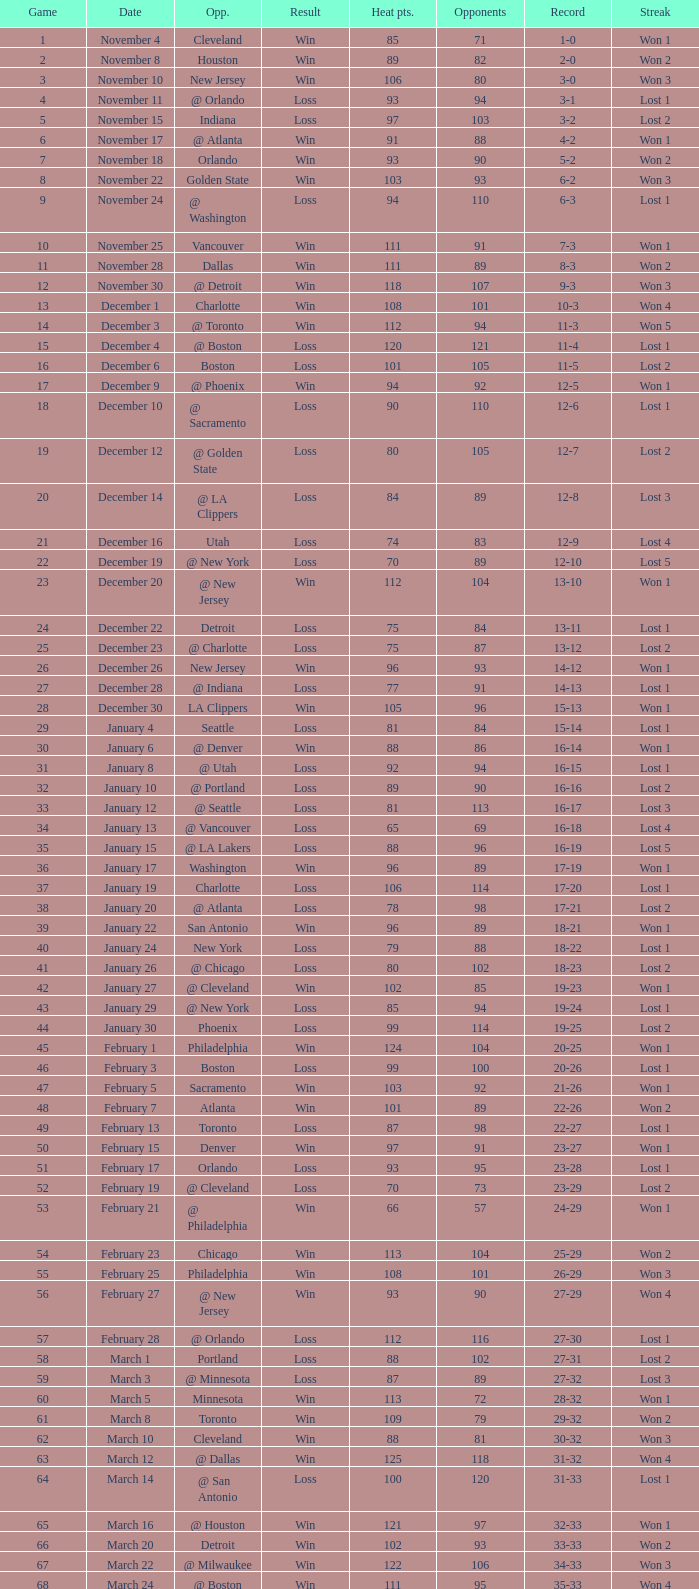Could you parse the entire table? {'header': ['Game', 'Date', 'Opp.', 'Result', 'Heat pts.', 'Opponents', 'Record', 'Streak'], 'rows': [['1', 'November 4', 'Cleveland', 'Win', '85', '71', '1-0', 'Won 1'], ['2', 'November 8', 'Houston', 'Win', '89', '82', '2-0', 'Won 2'], ['3', 'November 10', 'New Jersey', 'Win', '106', '80', '3-0', 'Won 3'], ['4', 'November 11', '@ Orlando', 'Loss', '93', '94', '3-1', 'Lost 1'], ['5', 'November 15', 'Indiana', 'Loss', '97', '103', '3-2', 'Lost 2'], ['6', 'November 17', '@ Atlanta', 'Win', '91', '88', '4-2', 'Won 1'], ['7', 'November 18', 'Orlando', 'Win', '93', '90', '5-2', 'Won 2'], ['8', 'November 22', 'Golden State', 'Win', '103', '93', '6-2', 'Won 3'], ['9', 'November 24', '@ Washington', 'Loss', '94', '110', '6-3', 'Lost 1'], ['10', 'November 25', 'Vancouver', 'Win', '111', '91', '7-3', 'Won 1'], ['11', 'November 28', 'Dallas', 'Win', '111', '89', '8-3', 'Won 2'], ['12', 'November 30', '@ Detroit', 'Win', '118', '107', '9-3', 'Won 3'], ['13', 'December 1', 'Charlotte', 'Win', '108', '101', '10-3', 'Won 4'], ['14', 'December 3', '@ Toronto', 'Win', '112', '94', '11-3', 'Won 5'], ['15', 'December 4', '@ Boston', 'Loss', '120', '121', '11-4', 'Lost 1'], ['16', 'December 6', 'Boston', 'Loss', '101', '105', '11-5', 'Lost 2'], ['17', 'December 9', '@ Phoenix', 'Win', '94', '92', '12-5', 'Won 1'], ['18', 'December 10', '@ Sacramento', 'Loss', '90', '110', '12-6', 'Lost 1'], ['19', 'December 12', '@ Golden State', 'Loss', '80', '105', '12-7', 'Lost 2'], ['20', 'December 14', '@ LA Clippers', 'Loss', '84', '89', '12-8', 'Lost 3'], ['21', 'December 16', 'Utah', 'Loss', '74', '83', '12-9', 'Lost 4'], ['22', 'December 19', '@ New York', 'Loss', '70', '89', '12-10', 'Lost 5'], ['23', 'December 20', '@ New Jersey', 'Win', '112', '104', '13-10', 'Won 1'], ['24', 'December 22', 'Detroit', 'Loss', '75', '84', '13-11', 'Lost 1'], ['25', 'December 23', '@ Charlotte', 'Loss', '75', '87', '13-12', 'Lost 2'], ['26', 'December 26', 'New Jersey', 'Win', '96', '93', '14-12', 'Won 1'], ['27', 'December 28', '@ Indiana', 'Loss', '77', '91', '14-13', 'Lost 1'], ['28', 'December 30', 'LA Clippers', 'Win', '105', '96', '15-13', 'Won 1'], ['29', 'January 4', 'Seattle', 'Loss', '81', '84', '15-14', 'Lost 1'], ['30', 'January 6', '@ Denver', 'Win', '88', '86', '16-14', 'Won 1'], ['31', 'January 8', '@ Utah', 'Loss', '92', '94', '16-15', 'Lost 1'], ['32', 'January 10', '@ Portland', 'Loss', '89', '90', '16-16', 'Lost 2'], ['33', 'January 12', '@ Seattle', 'Loss', '81', '113', '16-17', 'Lost 3'], ['34', 'January 13', '@ Vancouver', 'Loss', '65', '69', '16-18', 'Lost 4'], ['35', 'January 15', '@ LA Lakers', 'Loss', '88', '96', '16-19', 'Lost 5'], ['36', 'January 17', 'Washington', 'Win', '96', '89', '17-19', 'Won 1'], ['37', 'January 19', 'Charlotte', 'Loss', '106', '114', '17-20', 'Lost 1'], ['38', 'January 20', '@ Atlanta', 'Loss', '78', '98', '17-21', 'Lost 2'], ['39', 'January 22', 'San Antonio', 'Win', '96', '89', '18-21', 'Won 1'], ['40', 'January 24', 'New York', 'Loss', '79', '88', '18-22', 'Lost 1'], ['41', 'January 26', '@ Chicago', 'Loss', '80', '102', '18-23', 'Lost 2'], ['42', 'January 27', '@ Cleveland', 'Win', '102', '85', '19-23', 'Won 1'], ['43', 'January 29', '@ New York', 'Loss', '85', '94', '19-24', 'Lost 1'], ['44', 'January 30', 'Phoenix', 'Loss', '99', '114', '19-25', 'Lost 2'], ['45', 'February 1', 'Philadelphia', 'Win', '124', '104', '20-25', 'Won 1'], ['46', 'February 3', 'Boston', 'Loss', '99', '100', '20-26', 'Lost 1'], ['47', 'February 5', 'Sacramento', 'Win', '103', '92', '21-26', 'Won 1'], ['48', 'February 7', 'Atlanta', 'Win', '101', '89', '22-26', 'Won 2'], ['49', 'February 13', 'Toronto', 'Loss', '87', '98', '22-27', 'Lost 1'], ['50', 'February 15', 'Denver', 'Win', '97', '91', '23-27', 'Won 1'], ['51', 'February 17', 'Orlando', 'Loss', '93', '95', '23-28', 'Lost 1'], ['52', 'February 19', '@ Cleveland', 'Loss', '70', '73', '23-29', 'Lost 2'], ['53', 'February 21', '@ Philadelphia', 'Win', '66', '57', '24-29', 'Won 1'], ['54', 'February 23', 'Chicago', 'Win', '113', '104', '25-29', 'Won 2'], ['55', 'February 25', 'Philadelphia', 'Win', '108', '101', '26-29', 'Won 3'], ['56', 'February 27', '@ New Jersey', 'Win', '93', '90', '27-29', 'Won 4'], ['57', 'February 28', '@ Orlando', 'Loss', '112', '116', '27-30', 'Lost 1'], ['58', 'March 1', 'Portland', 'Loss', '88', '102', '27-31', 'Lost 2'], ['59', 'March 3', '@ Minnesota', 'Loss', '87', '89', '27-32', 'Lost 3'], ['60', 'March 5', 'Minnesota', 'Win', '113', '72', '28-32', 'Won 1'], ['61', 'March 8', 'Toronto', 'Win', '109', '79', '29-32', 'Won 2'], ['62', 'March 10', 'Cleveland', 'Win', '88', '81', '30-32', 'Won 3'], ['63', 'March 12', '@ Dallas', 'Win', '125', '118', '31-32', 'Won 4'], ['64', 'March 14', '@ San Antonio', 'Loss', '100', '120', '31-33', 'Lost 1'], ['65', 'March 16', '@ Houston', 'Win', '121', '97', '32-33', 'Won 1'], ['66', 'March 20', 'Detroit', 'Win', '102', '93', '33-33', 'Won 2'], ['67', 'March 22', '@ Milwaukee', 'Win', '122', '106', '34-33', 'Won 3'], ['68', 'March 24', '@ Boston', 'Win', '111', '95', '35-33', 'Won 4'], ['69', 'March 27', 'LA Lakers', 'Loss', '95', '106', '35-34', 'Lost 1'], ['70', 'March 29', 'Washington', 'Win', '112', '93', '36-34', 'Won 1'], ['71', 'March 30', '@ Detroit', 'Win', '95', '85', '37-34', 'Won 2'], ['72', 'April 2', 'Chicago', 'Loss', '92', '110', '37-35', 'Lost 1'], ['73', 'April 4', '@ Chicago', 'Loss', '92', '100', '37-36', 'Lost 2'], ['74', 'April 6', '@ Indiana', 'Loss', '95', '99', '37-37', 'Lost 3'], ['75', 'April 8', '@ Washington', 'Loss', '99', '111', '37-38', 'Lost 4'], ['76', 'April 10', '@ Charlotte', 'Win', '116', '95', '38-38', 'Won 1'], ['77', 'April 11', 'Milwaukee', 'Win', '115', '105', '39-38', 'Won 2'], ['78', 'April 13', 'New York', 'Win', '103', '95', '40-38', 'Won 3'], ['79', 'April 15', 'New Jersey', 'Win', '110', '90', '41-38', 'Won 4'], ['80', 'April 17', '@ Philadelphia', 'Loss', '86', '90', '41-39', 'Lost 1'], ['81', 'April 19', '@ Milwaukee', 'Win', '106', '100', '42-39', 'Won 1'], ['82', 'April 21', 'Atlanta', 'Loss', '92', '104', '42-40', 'Lost 1'], ['1', 'April 26 (First Round)', '@ Chicago', 'Loss', '85', '102', '0-1', 'Lost 1'], ['2', 'April 28 (First Round)', '@ Chicago', 'Loss', '75', '106', '0-2', 'Lost 2'], ['3', 'May 1 (First Round)', 'Chicago', 'Loss', '91', '112', '0-3', 'Lost 3']]} What is Heat Points, when Game is less than 80, and when Date is "April 26 (First Round)"? 85.0. 